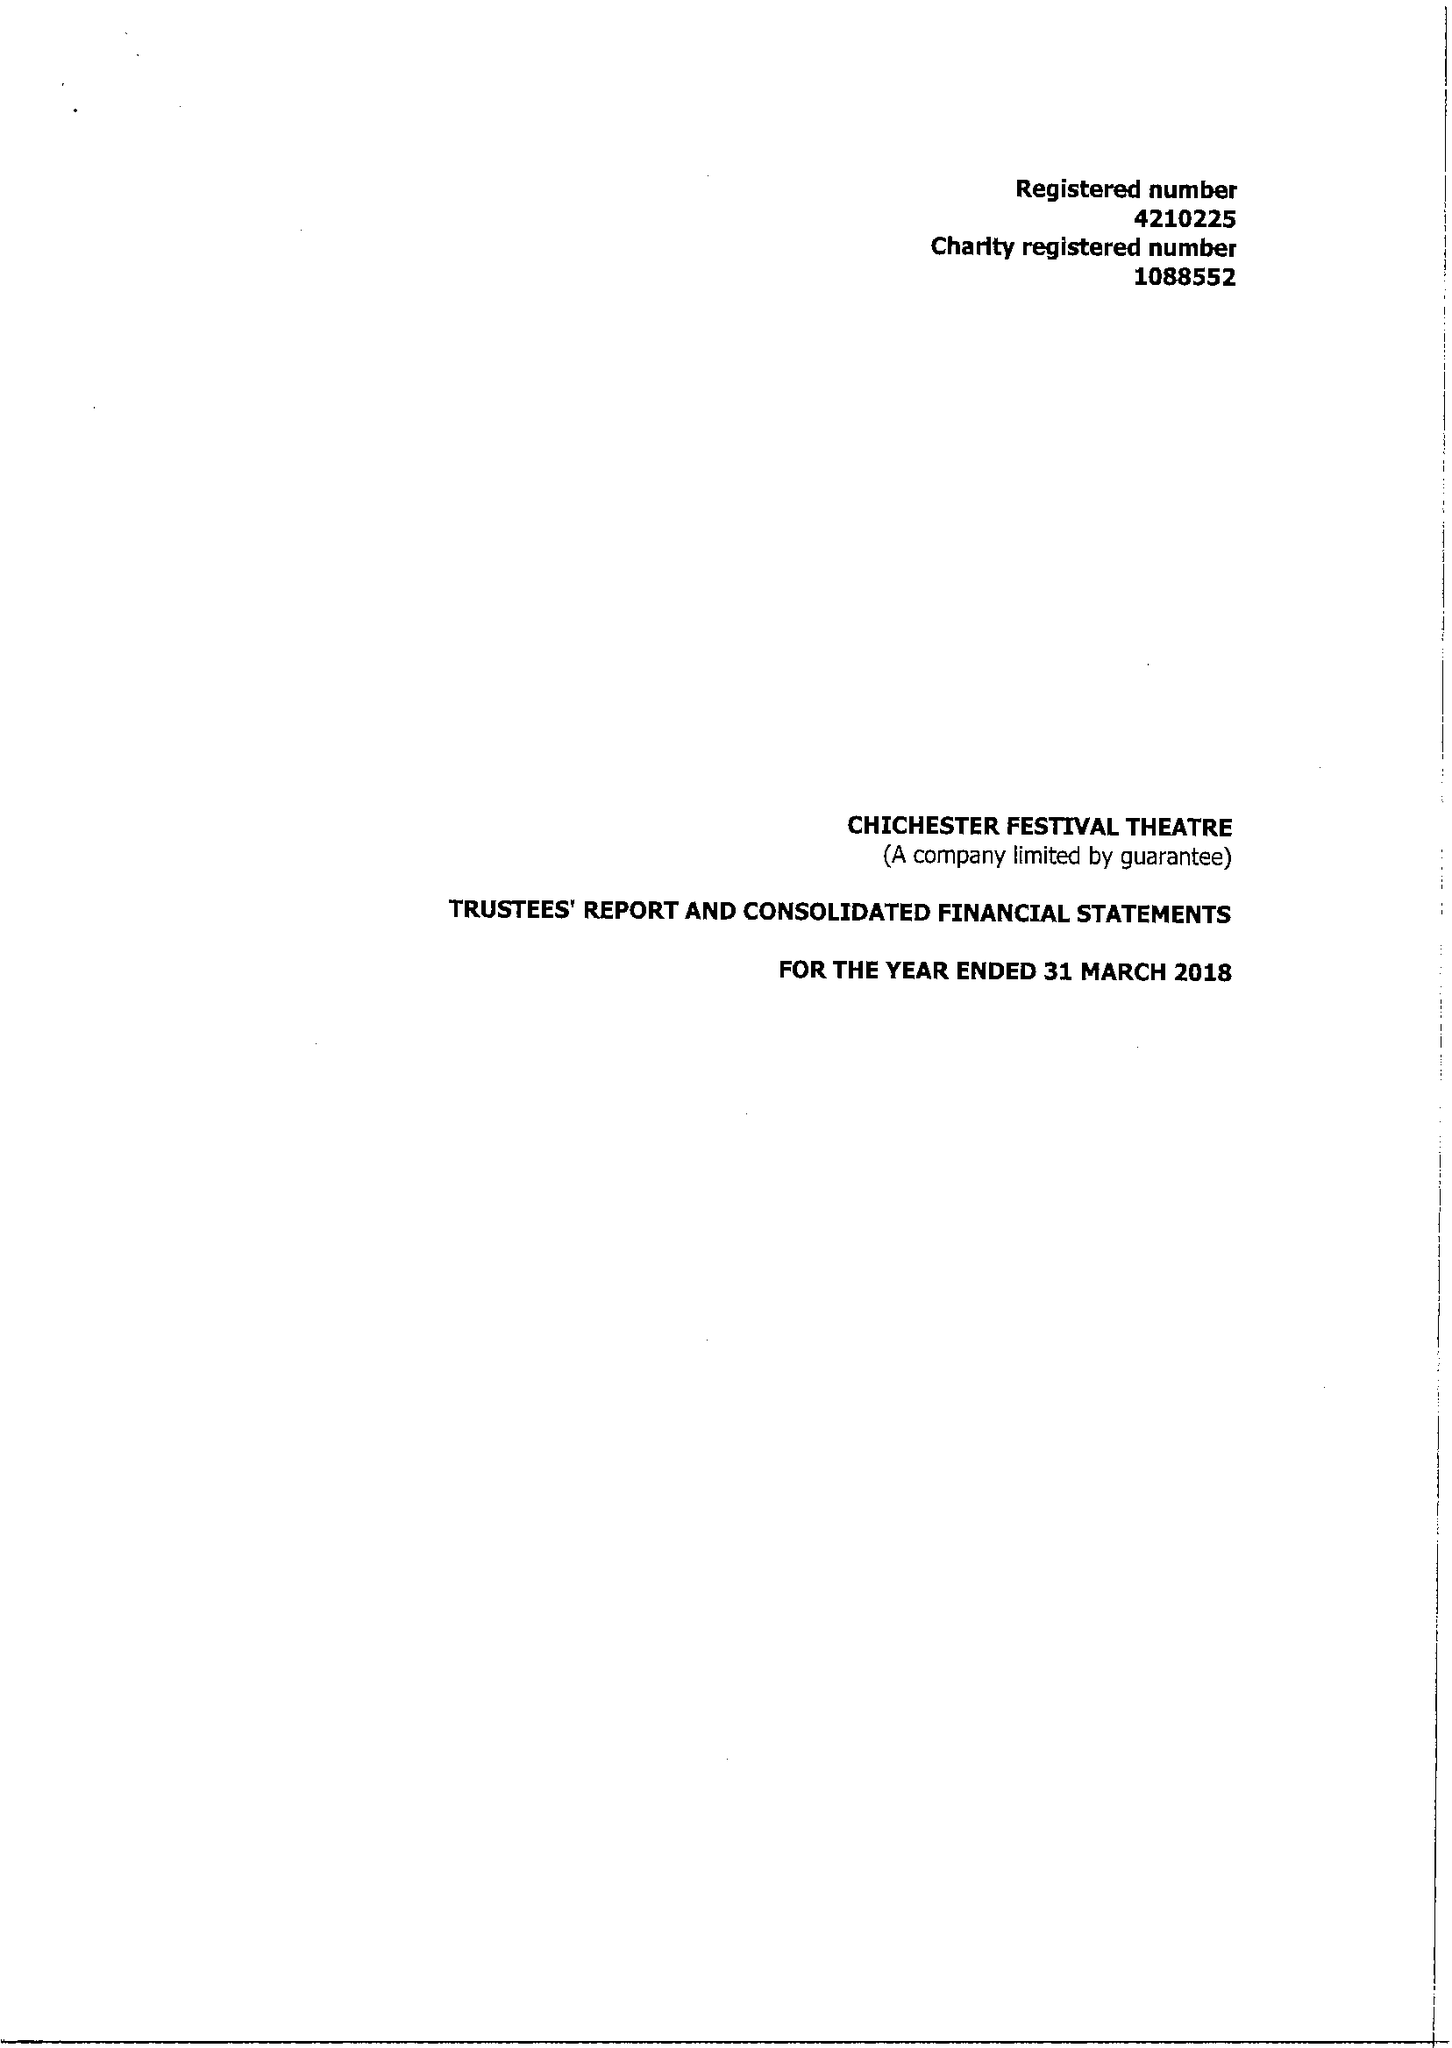What is the value for the address__post_town?
Answer the question using a single word or phrase. CHICHESTER 